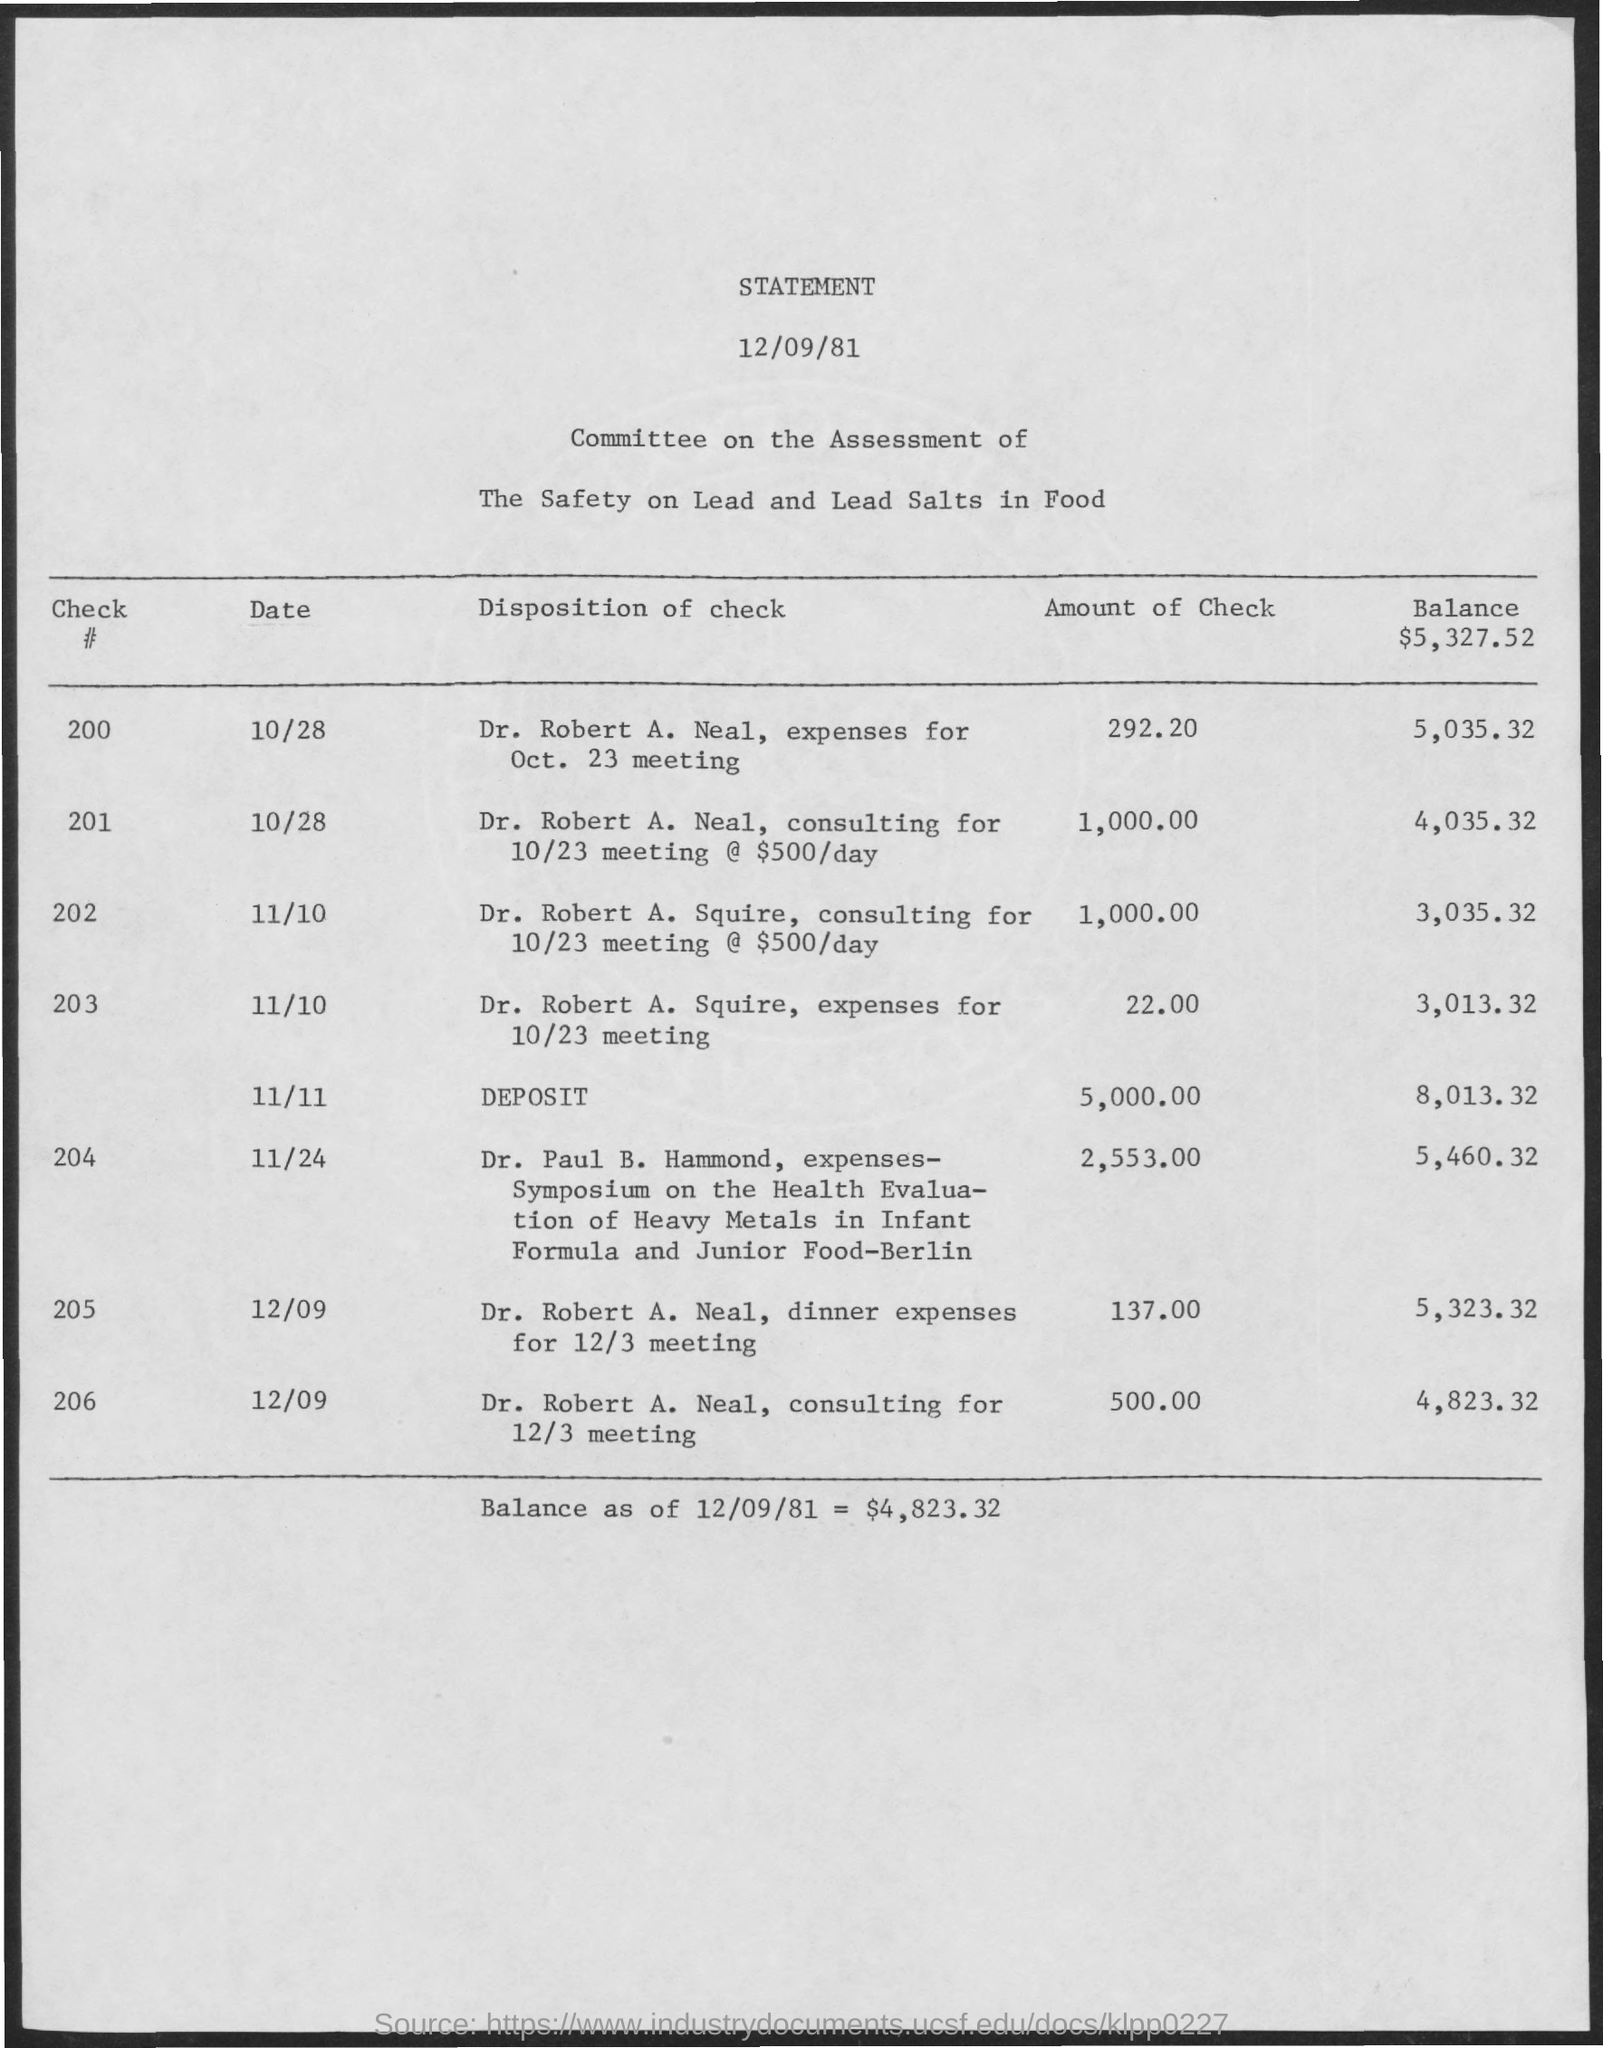What is the balance as of 12/09/81?
Ensure brevity in your answer.  $4,823.32. 